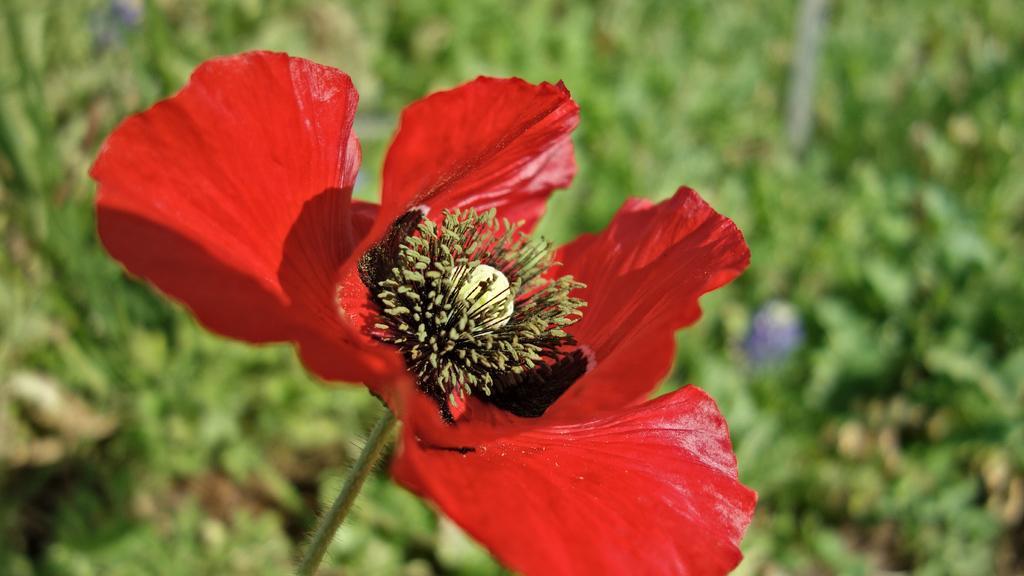Please provide a concise description of this image. In this picture we can see a red color flower here, we can see pollen grains, there is a blurry background here. 